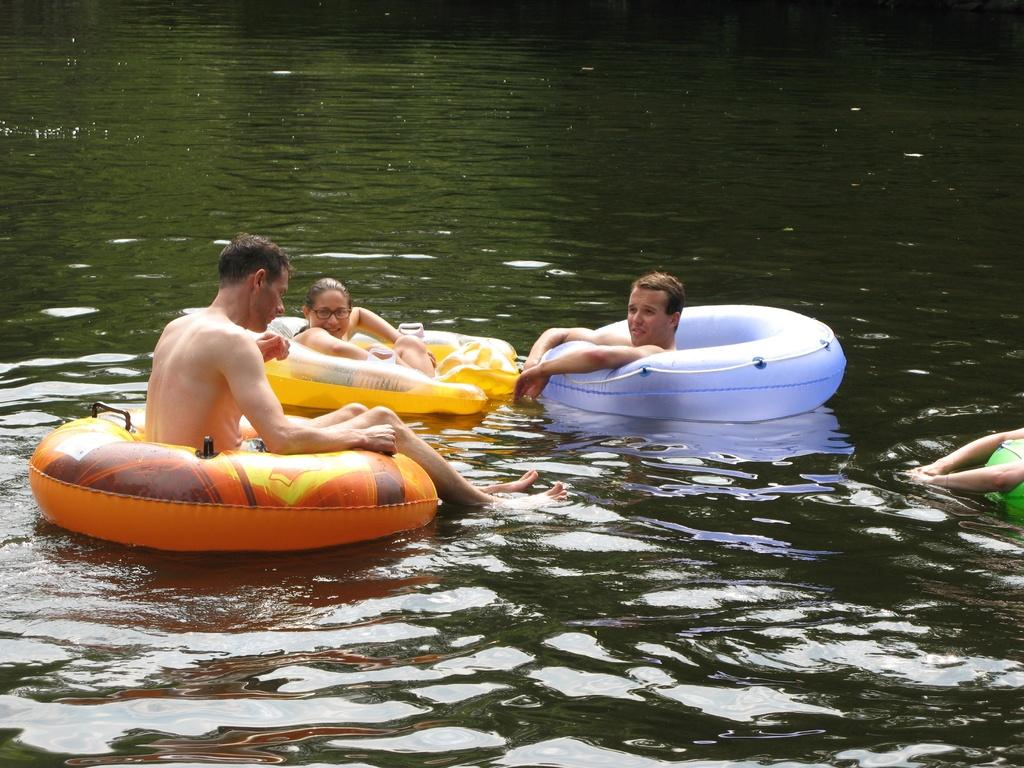What is the primary element visible in the image? There is water in the image. What objects can be seen in the water? There are tubes in the water. What activity are the people in the image engaged in? The people are swimming in the water. What type of kettle can be seen floating in the water? There is no kettle present in the image; it only features water, tubes, and people swimming. 